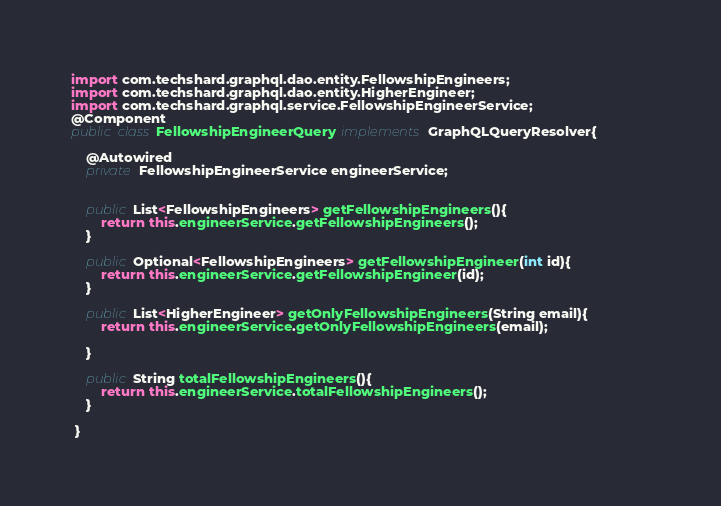Convert code to text. <code><loc_0><loc_0><loc_500><loc_500><_Java_>import com.techshard.graphql.dao.entity.FellowshipEngineers;
import com.techshard.graphql.dao.entity.HigherEngineer;
import com.techshard.graphql.service.FellowshipEngineerService;
@Component
public class FellowshipEngineerQuery implements GraphQLQueryResolver{

	@Autowired
	private FellowshipEngineerService engineerService;
	
	
	public List<FellowshipEngineers> getFellowshipEngineers(){
		return this.engineerService.getFellowshipEngineers();
	}
	
	public Optional<FellowshipEngineers> getFellowshipEngineer(int id){
		return this.engineerService.getFellowshipEngineer(id);
	}
	
 	public List<HigherEngineer> getOnlyFellowshipEngineers(String email){
 		return this.engineerService.getOnlyFellowshipEngineers(email);                           
 		
 	}
	
 	public String totalFellowshipEngineers(){
 		return this.engineerService.totalFellowshipEngineers();
 	}
	
 }
</code> 